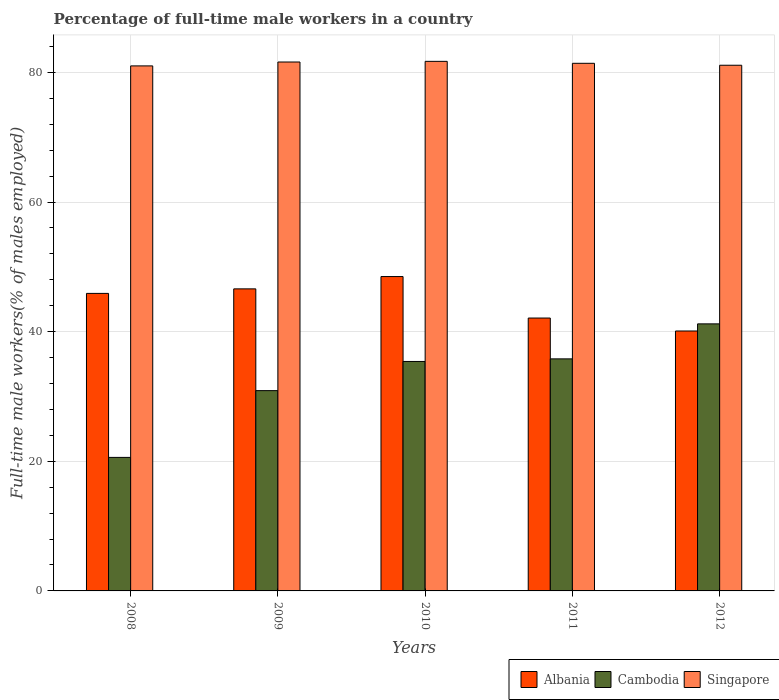How many groups of bars are there?
Your response must be concise. 5. Are the number of bars per tick equal to the number of legend labels?
Your response must be concise. Yes. Are the number of bars on each tick of the X-axis equal?
Give a very brief answer. Yes. How many bars are there on the 4th tick from the right?
Ensure brevity in your answer.  3. In how many cases, is the number of bars for a given year not equal to the number of legend labels?
Ensure brevity in your answer.  0. What is the percentage of full-time male workers in Albania in 2010?
Offer a terse response. 48.5. Across all years, what is the maximum percentage of full-time male workers in Singapore?
Give a very brief answer. 81.7. Across all years, what is the minimum percentage of full-time male workers in Singapore?
Offer a very short reply. 81. In which year was the percentage of full-time male workers in Cambodia minimum?
Provide a short and direct response. 2008. What is the total percentage of full-time male workers in Albania in the graph?
Your response must be concise. 223.2. What is the difference between the percentage of full-time male workers in Singapore in 2009 and that in 2012?
Make the answer very short. 0.5. What is the difference between the percentage of full-time male workers in Albania in 2009 and the percentage of full-time male workers in Cambodia in 2012?
Your response must be concise. 5.4. What is the average percentage of full-time male workers in Albania per year?
Offer a terse response. 44.64. In the year 2011, what is the difference between the percentage of full-time male workers in Albania and percentage of full-time male workers in Cambodia?
Your response must be concise. 6.3. What is the ratio of the percentage of full-time male workers in Albania in 2008 to that in 2012?
Ensure brevity in your answer.  1.14. Is the percentage of full-time male workers in Albania in 2010 less than that in 2012?
Offer a terse response. No. Is the difference between the percentage of full-time male workers in Albania in 2008 and 2009 greater than the difference between the percentage of full-time male workers in Cambodia in 2008 and 2009?
Provide a short and direct response. Yes. What is the difference between the highest and the second highest percentage of full-time male workers in Albania?
Your answer should be very brief. 1.9. What is the difference between the highest and the lowest percentage of full-time male workers in Cambodia?
Ensure brevity in your answer.  20.6. Is the sum of the percentage of full-time male workers in Singapore in 2011 and 2012 greater than the maximum percentage of full-time male workers in Cambodia across all years?
Provide a succinct answer. Yes. What does the 3rd bar from the left in 2011 represents?
Your answer should be compact. Singapore. What does the 3rd bar from the right in 2012 represents?
Give a very brief answer. Albania. Is it the case that in every year, the sum of the percentage of full-time male workers in Cambodia and percentage of full-time male workers in Singapore is greater than the percentage of full-time male workers in Albania?
Offer a very short reply. Yes. How many years are there in the graph?
Provide a succinct answer. 5. Are the values on the major ticks of Y-axis written in scientific E-notation?
Your answer should be very brief. No. Where does the legend appear in the graph?
Keep it short and to the point. Bottom right. How are the legend labels stacked?
Ensure brevity in your answer.  Horizontal. What is the title of the graph?
Your answer should be very brief. Percentage of full-time male workers in a country. Does "Turkmenistan" appear as one of the legend labels in the graph?
Your answer should be very brief. No. What is the label or title of the Y-axis?
Provide a succinct answer. Full-time male workers(% of males employed). What is the Full-time male workers(% of males employed) of Albania in 2008?
Keep it short and to the point. 45.9. What is the Full-time male workers(% of males employed) of Cambodia in 2008?
Keep it short and to the point. 20.6. What is the Full-time male workers(% of males employed) of Albania in 2009?
Your answer should be compact. 46.6. What is the Full-time male workers(% of males employed) of Cambodia in 2009?
Provide a succinct answer. 30.9. What is the Full-time male workers(% of males employed) in Singapore in 2009?
Your answer should be compact. 81.6. What is the Full-time male workers(% of males employed) of Albania in 2010?
Keep it short and to the point. 48.5. What is the Full-time male workers(% of males employed) in Cambodia in 2010?
Give a very brief answer. 35.4. What is the Full-time male workers(% of males employed) in Singapore in 2010?
Your answer should be very brief. 81.7. What is the Full-time male workers(% of males employed) of Albania in 2011?
Offer a very short reply. 42.1. What is the Full-time male workers(% of males employed) in Cambodia in 2011?
Provide a short and direct response. 35.8. What is the Full-time male workers(% of males employed) in Singapore in 2011?
Provide a succinct answer. 81.4. What is the Full-time male workers(% of males employed) in Albania in 2012?
Ensure brevity in your answer.  40.1. What is the Full-time male workers(% of males employed) in Cambodia in 2012?
Offer a terse response. 41.2. What is the Full-time male workers(% of males employed) in Singapore in 2012?
Make the answer very short. 81.1. Across all years, what is the maximum Full-time male workers(% of males employed) in Albania?
Provide a short and direct response. 48.5. Across all years, what is the maximum Full-time male workers(% of males employed) in Cambodia?
Offer a very short reply. 41.2. Across all years, what is the maximum Full-time male workers(% of males employed) of Singapore?
Your answer should be very brief. 81.7. Across all years, what is the minimum Full-time male workers(% of males employed) in Albania?
Keep it short and to the point. 40.1. Across all years, what is the minimum Full-time male workers(% of males employed) in Cambodia?
Make the answer very short. 20.6. What is the total Full-time male workers(% of males employed) of Albania in the graph?
Your response must be concise. 223.2. What is the total Full-time male workers(% of males employed) in Cambodia in the graph?
Give a very brief answer. 163.9. What is the total Full-time male workers(% of males employed) of Singapore in the graph?
Make the answer very short. 406.8. What is the difference between the Full-time male workers(% of males employed) in Albania in 2008 and that in 2009?
Provide a succinct answer. -0.7. What is the difference between the Full-time male workers(% of males employed) of Cambodia in 2008 and that in 2009?
Provide a succinct answer. -10.3. What is the difference between the Full-time male workers(% of males employed) of Singapore in 2008 and that in 2009?
Provide a short and direct response. -0.6. What is the difference between the Full-time male workers(% of males employed) in Albania in 2008 and that in 2010?
Keep it short and to the point. -2.6. What is the difference between the Full-time male workers(% of males employed) in Cambodia in 2008 and that in 2010?
Offer a very short reply. -14.8. What is the difference between the Full-time male workers(% of males employed) in Cambodia in 2008 and that in 2011?
Keep it short and to the point. -15.2. What is the difference between the Full-time male workers(% of males employed) in Singapore in 2008 and that in 2011?
Keep it short and to the point. -0.4. What is the difference between the Full-time male workers(% of males employed) of Albania in 2008 and that in 2012?
Provide a short and direct response. 5.8. What is the difference between the Full-time male workers(% of males employed) of Cambodia in 2008 and that in 2012?
Provide a succinct answer. -20.6. What is the difference between the Full-time male workers(% of males employed) of Singapore in 2008 and that in 2012?
Your response must be concise. -0.1. What is the difference between the Full-time male workers(% of males employed) of Cambodia in 2009 and that in 2010?
Provide a short and direct response. -4.5. What is the difference between the Full-time male workers(% of males employed) in Singapore in 2009 and that in 2011?
Ensure brevity in your answer.  0.2. What is the difference between the Full-time male workers(% of males employed) of Albania in 2009 and that in 2012?
Your answer should be compact. 6.5. What is the difference between the Full-time male workers(% of males employed) of Cambodia in 2009 and that in 2012?
Make the answer very short. -10.3. What is the difference between the Full-time male workers(% of males employed) in Singapore in 2009 and that in 2012?
Ensure brevity in your answer.  0.5. What is the difference between the Full-time male workers(% of males employed) of Albania in 2010 and that in 2011?
Offer a very short reply. 6.4. What is the difference between the Full-time male workers(% of males employed) of Cambodia in 2010 and that in 2012?
Your answer should be very brief. -5.8. What is the difference between the Full-time male workers(% of males employed) of Cambodia in 2011 and that in 2012?
Offer a very short reply. -5.4. What is the difference between the Full-time male workers(% of males employed) in Albania in 2008 and the Full-time male workers(% of males employed) in Singapore in 2009?
Offer a very short reply. -35.7. What is the difference between the Full-time male workers(% of males employed) of Cambodia in 2008 and the Full-time male workers(% of males employed) of Singapore in 2009?
Ensure brevity in your answer.  -61. What is the difference between the Full-time male workers(% of males employed) of Albania in 2008 and the Full-time male workers(% of males employed) of Cambodia in 2010?
Offer a terse response. 10.5. What is the difference between the Full-time male workers(% of males employed) in Albania in 2008 and the Full-time male workers(% of males employed) in Singapore in 2010?
Your answer should be very brief. -35.8. What is the difference between the Full-time male workers(% of males employed) in Cambodia in 2008 and the Full-time male workers(% of males employed) in Singapore in 2010?
Offer a terse response. -61.1. What is the difference between the Full-time male workers(% of males employed) in Albania in 2008 and the Full-time male workers(% of males employed) in Cambodia in 2011?
Make the answer very short. 10.1. What is the difference between the Full-time male workers(% of males employed) in Albania in 2008 and the Full-time male workers(% of males employed) in Singapore in 2011?
Your answer should be compact. -35.5. What is the difference between the Full-time male workers(% of males employed) in Cambodia in 2008 and the Full-time male workers(% of males employed) in Singapore in 2011?
Your response must be concise. -60.8. What is the difference between the Full-time male workers(% of males employed) of Albania in 2008 and the Full-time male workers(% of males employed) of Singapore in 2012?
Keep it short and to the point. -35.2. What is the difference between the Full-time male workers(% of males employed) in Cambodia in 2008 and the Full-time male workers(% of males employed) in Singapore in 2012?
Your answer should be very brief. -60.5. What is the difference between the Full-time male workers(% of males employed) of Albania in 2009 and the Full-time male workers(% of males employed) of Cambodia in 2010?
Offer a very short reply. 11.2. What is the difference between the Full-time male workers(% of males employed) in Albania in 2009 and the Full-time male workers(% of males employed) in Singapore in 2010?
Your answer should be very brief. -35.1. What is the difference between the Full-time male workers(% of males employed) in Cambodia in 2009 and the Full-time male workers(% of males employed) in Singapore in 2010?
Your response must be concise. -50.8. What is the difference between the Full-time male workers(% of males employed) of Albania in 2009 and the Full-time male workers(% of males employed) of Singapore in 2011?
Give a very brief answer. -34.8. What is the difference between the Full-time male workers(% of males employed) of Cambodia in 2009 and the Full-time male workers(% of males employed) of Singapore in 2011?
Provide a succinct answer. -50.5. What is the difference between the Full-time male workers(% of males employed) of Albania in 2009 and the Full-time male workers(% of males employed) of Cambodia in 2012?
Provide a succinct answer. 5.4. What is the difference between the Full-time male workers(% of males employed) of Albania in 2009 and the Full-time male workers(% of males employed) of Singapore in 2012?
Your answer should be compact. -34.5. What is the difference between the Full-time male workers(% of males employed) of Cambodia in 2009 and the Full-time male workers(% of males employed) of Singapore in 2012?
Offer a terse response. -50.2. What is the difference between the Full-time male workers(% of males employed) in Albania in 2010 and the Full-time male workers(% of males employed) in Cambodia in 2011?
Offer a terse response. 12.7. What is the difference between the Full-time male workers(% of males employed) of Albania in 2010 and the Full-time male workers(% of males employed) of Singapore in 2011?
Ensure brevity in your answer.  -32.9. What is the difference between the Full-time male workers(% of males employed) of Cambodia in 2010 and the Full-time male workers(% of males employed) of Singapore in 2011?
Offer a terse response. -46. What is the difference between the Full-time male workers(% of males employed) in Albania in 2010 and the Full-time male workers(% of males employed) in Cambodia in 2012?
Your answer should be compact. 7.3. What is the difference between the Full-time male workers(% of males employed) in Albania in 2010 and the Full-time male workers(% of males employed) in Singapore in 2012?
Provide a succinct answer. -32.6. What is the difference between the Full-time male workers(% of males employed) in Cambodia in 2010 and the Full-time male workers(% of males employed) in Singapore in 2012?
Ensure brevity in your answer.  -45.7. What is the difference between the Full-time male workers(% of males employed) of Albania in 2011 and the Full-time male workers(% of males employed) of Cambodia in 2012?
Your answer should be very brief. 0.9. What is the difference between the Full-time male workers(% of males employed) in Albania in 2011 and the Full-time male workers(% of males employed) in Singapore in 2012?
Your response must be concise. -39. What is the difference between the Full-time male workers(% of males employed) of Cambodia in 2011 and the Full-time male workers(% of males employed) of Singapore in 2012?
Ensure brevity in your answer.  -45.3. What is the average Full-time male workers(% of males employed) of Albania per year?
Your response must be concise. 44.64. What is the average Full-time male workers(% of males employed) of Cambodia per year?
Keep it short and to the point. 32.78. What is the average Full-time male workers(% of males employed) in Singapore per year?
Your response must be concise. 81.36. In the year 2008, what is the difference between the Full-time male workers(% of males employed) of Albania and Full-time male workers(% of males employed) of Cambodia?
Your answer should be very brief. 25.3. In the year 2008, what is the difference between the Full-time male workers(% of males employed) in Albania and Full-time male workers(% of males employed) in Singapore?
Make the answer very short. -35.1. In the year 2008, what is the difference between the Full-time male workers(% of males employed) in Cambodia and Full-time male workers(% of males employed) in Singapore?
Your response must be concise. -60.4. In the year 2009, what is the difference between the Full-time male workers(% of males employed) of Albania and Full-time male workers(% of males employed) of Singapore?
Provide a succinct answer. -35. In the year 2009, what is the difference between the Full-time male workers(% of males employed) in Cambodia and Full-time male workers(% of males employed) in Singapore?
Provide a short and direct response. -50.7. In the year 2010, what is the difference between the Full-time male workers(% of males employed) in Albania and Full-time male workers(% of males employed) in Singapore?
Make the answer very short. -33.2. In the year 2010, what is the difference between the Full-time male workers(% of males employed) of Cambodia and Full-time male workers(% of males employed) of Singapore?
Your answer should be very brief. -46.3. In the year 2011, what is the difference between the Full-time male workers(% of males employed) of Albania and Full-time male workers(% of males employed) of Singapore?
Ensure brevity in your answer.  -39.3. In the year 2011, what is the difference between the Full-time male workers(% of males employed) in Cambodia and Full-time male workers(% of males employed) in Singapore?
Provide a succinct answer. -45.6. In the year 2012, what is the difference between the Full-time male workers(% of males employed) in Albania and Full-time male workers(% of males employed) in Cambodia?
Offer a terse response. -1.1. In the year 2012, what is the difference between the Full-time male workers(% of males employed) of Albania and Full-time male workers(% of males employed) of Singapore?
Give a very brief answer. -41. In the year 2012, what is the difference between the Full-time male workers(% of males employed) in Cambodia and Full-time male workers(% of males employed) in Singapore?
Your answer should be very brief. -39.9. What is the ratio of the Full-time male workers(% of males employed) in Singapore in 2008 to that in 2009?
Offer a terse response. 0.99. What is the ratio of the Full-time male workers(% of males employed) of Albania in 2008 to that in 2010?
Your response must be concise. 0.95. What is the ratio of the Full-time male workers(% of males employed) in Cambodia in 2008 to that in 2010?
Keep it short and to the point. 0.58. What is the ratio of the Full-time male workers(% of males employed) in Albania in 2008 to that in 2011?
Ensure brevity in your answer.  1.09. What is the ratio of the Full-time male workers(% of males employed) in Cambodia in 2008 to that in 2011?
Provide a short and direct response. 0.58. What is the ratio of the Full-time male workers(% of males employed) in Singapore in 2008 to that in 2011?
Keep it short and to the point. 1. What is the ratio of the Full-time male workers(% of males employed) of Albania in 2008 to that in 2012?
Your answer should be compact. 1.14. What is the ratio of the Full-time male workers(% of males employed) in Cambodia in 2008 to that in 2012?
Provide a succinct answer. 0.5. What is the ratio of the Full-time male workers(% of males employed) in Singapore in 2008 to that in 2012?
Give a very brief answer. 1. What is the ratio of the Full-time male workers(% of males employed) of Albania in 2009 to that in 2010?
Offer a terse response. 0.96. What is the ratio of the Full-time male workers(% of males employed) in Cambodia in 2009 to that in 2010?
Offer a terse response. 0.87. What is the ratio of the Full-time male workers(% of males employed) in Albania in 2009 to that in 2011?
Offer a very short reply. 1.11. What is the ratio of the Full-time male workers(% of males employed) in Cambodia in 2009 to that in 2011?
Provide a short and direct response. 0.86. What is the ratio of the Full-time male workers(% of males employed) of Singapore in 2009 to that in 2011?
Ensure brevity in your answer.  1. What is the ratio of the Full-time male workers(% of males employed) in Albania in 2009 to that in 2012?
Keep it short and to the point. 1.16. What is the ratio of the Full-time male workers(% of males employed) in Cambodia in 2009 to that in 2012?
Keep it short and to the point. 0.75. What is the ratio of the Full-time male workers(% of males employed) of Albania in 2010 to that in 2011?
Make the answer very short. 1.15. What is the ratio of the Full-time male workers(% of males employed) in Cambodia in 2010 to that in 2011?
Ensure brevity in your answer.  0.99. What is the ratio of the Full-time male workers(% of males employed) of Albania in 2010 to that in 2012?
Offer a terse response. 1.21. What is the ratio of the Full-time male workers(% of males employed) of Cambodia in 2010 to that in 2012?
Ensure brevity in your answer.  0.86. What is the ratio of the Full-time male workers(% of males employed) in Singapore in 2010 to that in 2012?
Give a very brief answer. 1.01. What is the ratio of the Full-time male workers(% of males employed) of Albania in 2011 to that in 2012?
Offer a terse response. 1.05. What is the ratio of the Full-time male workers(% of males employed) of Cambodia in 2011 to that in 2012?
Your response must be concise. 0.87. What is the difference between the highest and the second highest Full-time male workers(% of males employed) in Albania?
Offer a terse response. 1.9. What is the difference between the highest and the lowest Full-time male workers(% of males employed) in Albania?
Make the answer very short. 8.4. What is the difference between the highest and the lowest Full-time male workers(% of males employed) in Cambodia?
Provide a short and direct response. 20.6. 